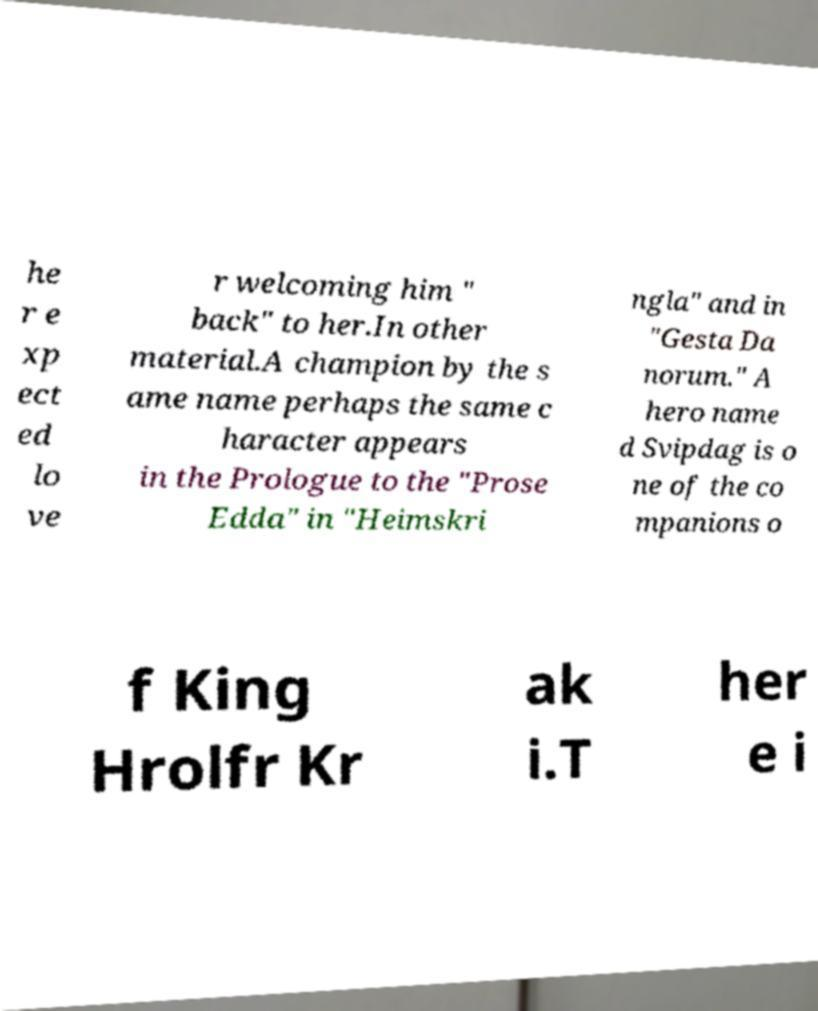There's text embedded in this image that I need extracted. Can you transcribe it verbatim? he r e xp ect ed lo ve r welcoming him " back" to her.In other material.A champion by the s ame name perhaps the same c haracter appears in the Prologue to the "Prose Edda" in "Heimskri ngla" and in "Gesta Da norum." A hero name d Svipdag is o ne of the co mpanions o f King Hrolfr Kr ak i.T her e i 